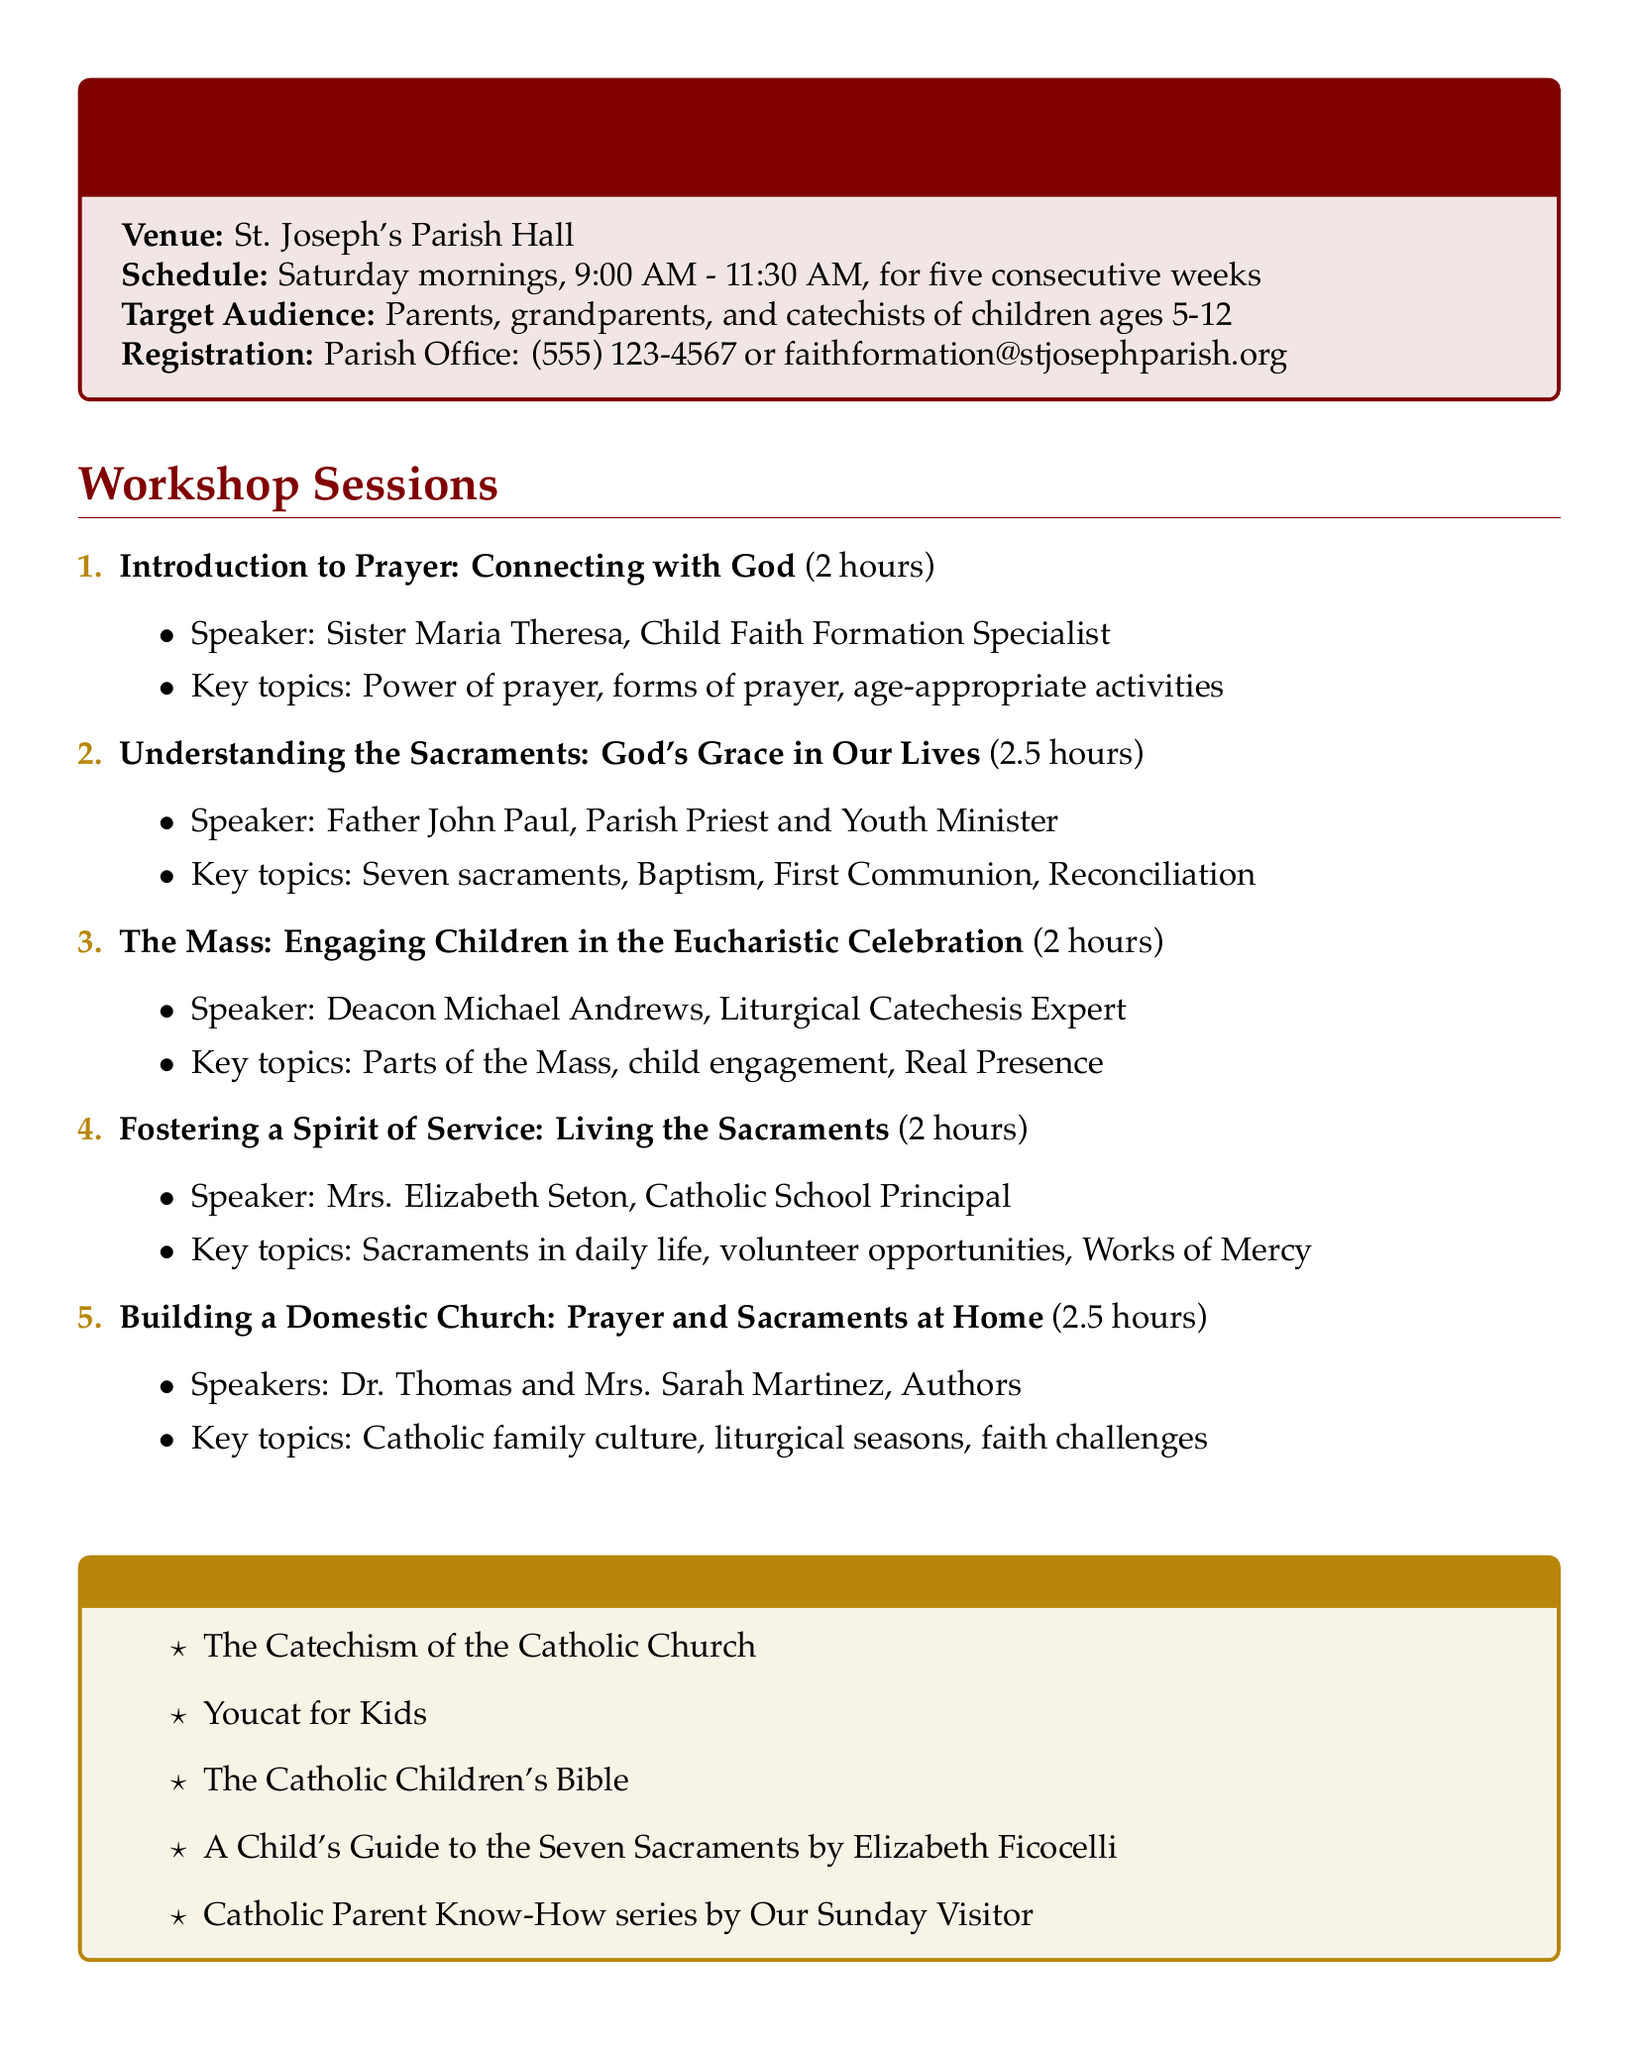What is the title of the workshop series? The title of the workshop series is the primary heading mentioned in the document.
Answer: Nurturing Faith: Teaching Children the Importance of Prayer and Sacraments Who is the speaker for the session on prayer? The document lists speakers for each session, indicating who will present on each topic.
Answer: Sister Maria Theresa, Child Faith Formation Specialist How long is the session on understanding the sacraments? The duration of each session is specified, allowing for easy retrieval of session lengths.
Answer: 2.5 hours What venue will the workshops be held in? The venue is explicitly indicated as part of the introductory information in the document.
Answer: St. Joseph's Parish Hall What is the target audience for these workshops? The target audience is defined to clarify who should attend the workshops.
Answer: Parents, grandparents, and catechists of children ages 5-12 Which topic involves age-appropriate prayer activities? This requires connecting the session topics with their contents explicitly mentioned in the document.
Answer: Introduction to Prayer: Connecting with God What is one of the activities planned for the session on the Mass? Activities listed enhance engagement and understanding of the different workshop topics, which can be referenced.
Answer: Mass scavenger hunt worksheet How many sessions are part of the workshop series? By counting the items listed under workshop sessions, one can conclude the total number of workshops.
Answer: Five 